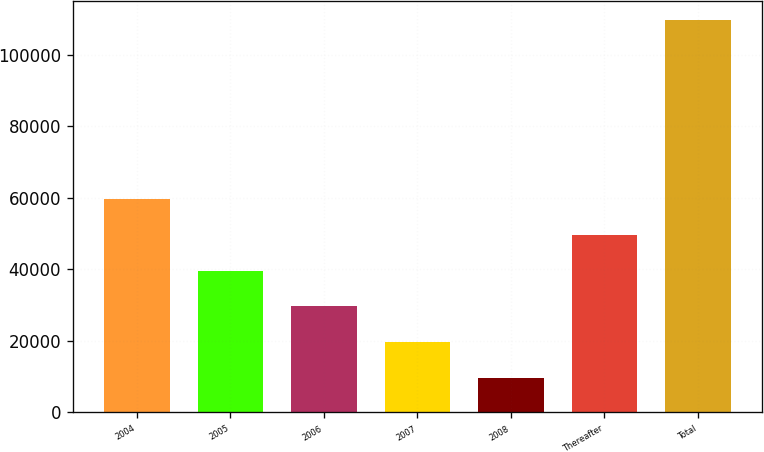Convert chart to OTSL. <chart><loc_0><loc_0><loc_500><loc_500><bar_chart><fcel>2004<fcel>2005<fcel>2006<fcel>2007<fcel>2008<fcel>Thereafter<fcel>Total<nl><fcel>59638<fcel>39621.2<fcel>29612.8<fcel>19604.4<fcel>9596<fcel>49629.6<fcel>109680<nl></chart> 